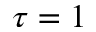<formula> <loc_0><loc_0><loc_500><loc_500>\tau = 1</formula> 